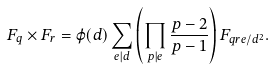<formula> <loc_0><loc_0><loc_500><loc_500>F _ { q } \times F _ { r } = \varphi ( d ) \sum _ { e | d } \left ( \prod _ { p | e } \frac { p - 2 } { p - 1 } \right ) F _ { q r e / d ^ { 2 } } .</formula> 